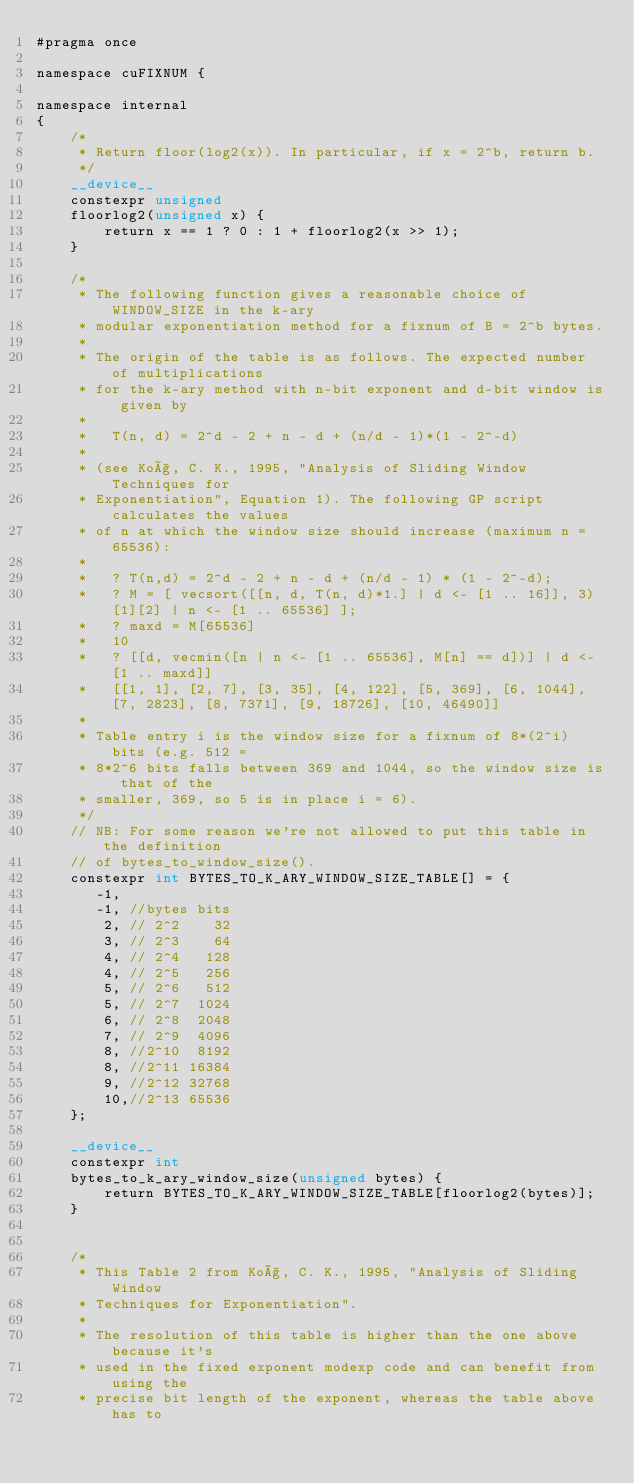<code> <loc_0><loc_0><loc_500><loc_500><_Cuda_>#pragma once

namespace cuFIXNUM {

namespace internal
{
    /*
     * Return floor(log2(x)). In particular, if x = 2^b, return b.
     */
    __device__
    constexpr unsigned
    floorlog2(unsigned x) {
        return x == 1 ? 0 : 1 + floorlog2(x >> 1);
    }

    /*
     * The following function gives a reasonable choice of WINDOW_SIZE in the k-ary
     * modular exponentiation method for a fixnum of B = 2^b bytes.
     *
     * The origin of the table is as follows. The expected number of multiplications
     * for the k-ary method with n-bit exponent and d-bit window is given by
     *
     *   T(n, d) = 2^d - 2 + n - d + (n/d - 1)*(1 - 2^-d)
     *
     * (see Koç, C. K., 1995, "Analysis of Sliding Window Techniques for
     * Exponentiation", Equation 1). The following GP script calculates the values
     * of n at which the window size should increase (maximum n = 65536):
     *
     *   ? T(n,d) = 2^d - 2 + n - d + (n/d - 1) * (1 - 2^-d);
     *   ? M = [ vecsort([[n, d, T(n, d)*1.] | d <- [1 .. 16]], 3)[1][2] | n <- [1 .. 65536] ];
     *   ? maxd = M[65536]
     *   10
     *   ? [[d, vecmin([n | n <- [1 .. 65536], M[n] == d])] | d <- [1 .. maxd]]
     *   [[1, 1], [2, 7], [3, 35], [4, 122], [5, 369], [6, 1044], [7, 2823], [8, 7371], [9, 18726], [10, 46490]]
     *
     * Table entry i is the window size for a fixnum of 8*(2^i) bits (e.g. 512 =
     * 8*2^6 bits falls between 369 and 1044, so the window size is that of the
     * smaller, 369, so 5 is in place i = 6).
     */
    // NB: For some reason we're not allowed to put this table in the definition
    // of bytes_to_window_size().
    constexpr int BYTES_TO_K_ARY_WINDOW_SIZE_TABLE[] = {
       -1,
       -1, //bytes bits
        2, // 2^2    32
        3, // 2^3    64
        4, // 2^4   128
        4, // 2^5   256
        5, // 2^6   512
        5, // 2^7  1024
        6, // 2^8  2048
        7, // 2^9  4096
        8, //2^10  8192
        8, //2^11 16384
        9, //2^12 32768
        10,//2^13 65536
    };

    __device__
    constexpr int
    bytes_to_k_ary_window_size(unsigned bytes) {
        return BYTES_TO_K_ARY_WINDOW_SIZE_TABLE[floorlog2(bytes)];
    }


    /*
     * This Table 2 from Koç, C. K., 1995, "Analysis of Sliding Window
     * Techniques for Exponentiation".
     *
     * The resolution of this table is higher than the one above because it's
     * used in the fixed exponent modexp code and can benefit from using the
     * precise bit length of the exponent, whereas the table above has to</code> 